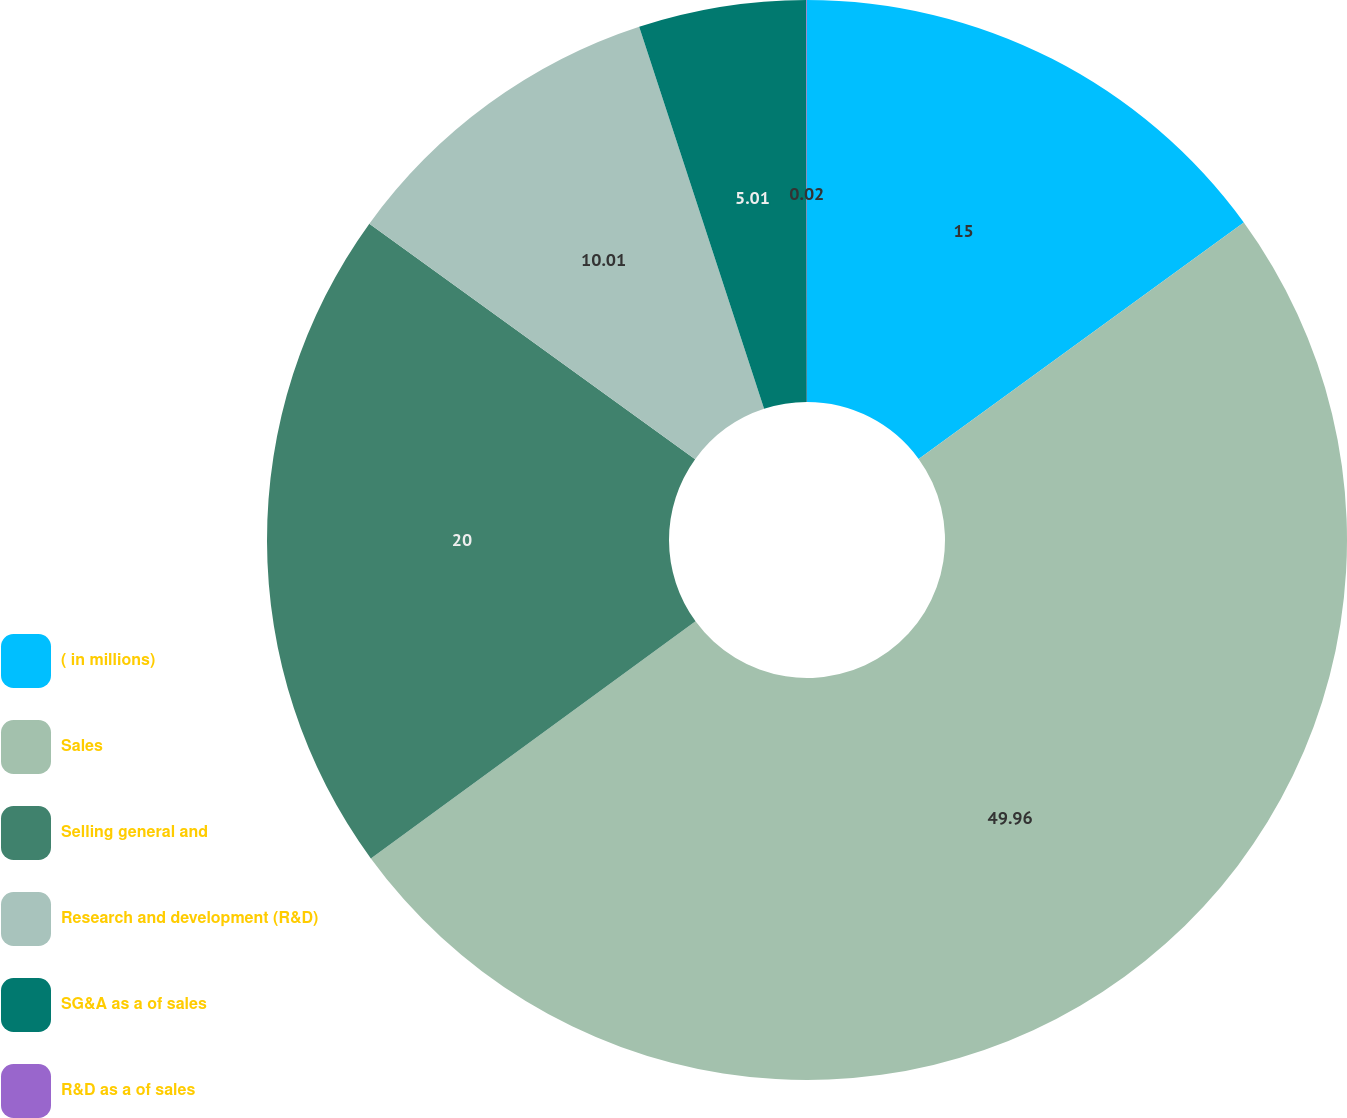<chart> <loc_0><loc_0><loc_500><loc_500><pie_chart><fcel>( in millions)<fcel>Sales<fcel>Selling general and<fcel>Research and development (R&D)<fcel>SG&A as a of sales<fcel>R&D as a of sales<nl><fcel>15.0%<fcel>49.97%<fcel>20.0%<fcel>10.01%<fcel>5.01%<fcel>0.02%<nl></chart> 